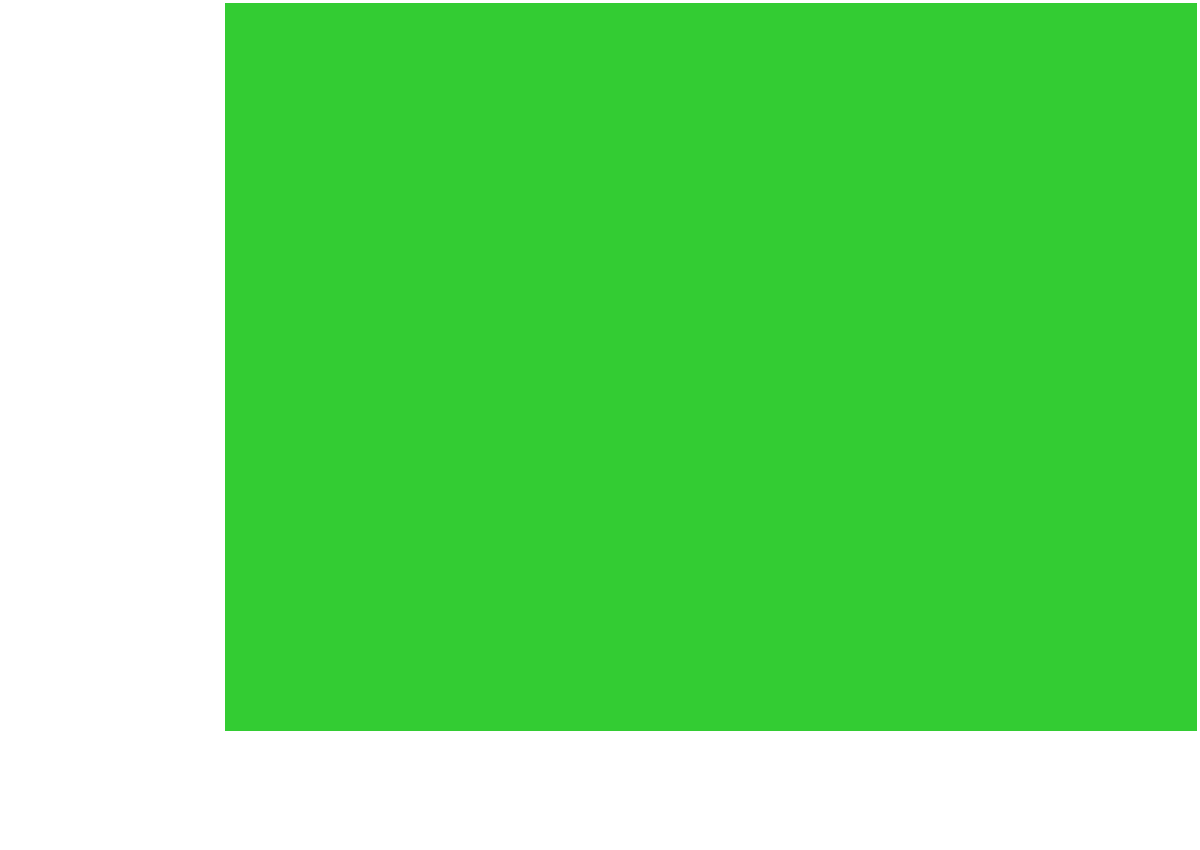As a sports journalist covering the Iranian Pro League, you're tasked with reporting on the new Azadi Stadium soccer field. The groundskeeper informs you that the field measures 120 meters in length and 90 meters in width. Calculate the total area of the playing surface in square meters. To calculate the area of the rectangular soccer field, we need to multiply its length by its width. Let's break it down step-by-step:

1. Given dimensions:
   Length ($l$) = 120 meters
   Width ($w$) = 90 meters

2. The formula for the area of a rectangle is:
   $A = l \times w$

3. Substituting the values:
   $A = 120 \text{ m} \times 90 \text{ m}$

4. Calculating:
   $A = 10,800 \text{ m}^2$

Therefore, the total area of the Azadi Stadium soccer field is 10,800 square meters.
Answer: 10,800 m² 